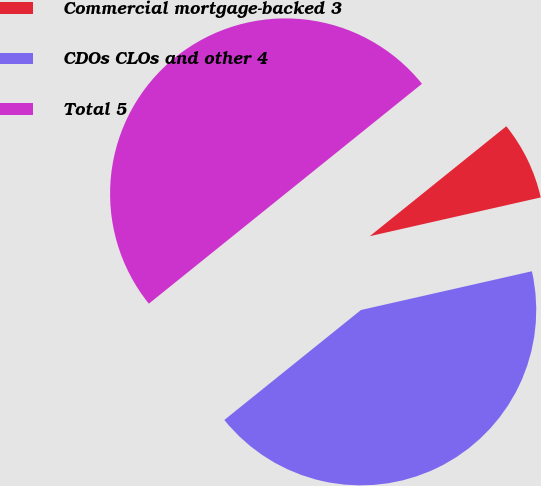<chart> <loc_0><loc_0><loc_500><loc_500><pie_chart><fcel>Commercial mortgage-backed 3<fcel>CDOs CLOs and other 4<fcel>Total 5<nl><fcel>7.24%<fcel>42.76%<fcel>50.0%<nl></chart> 